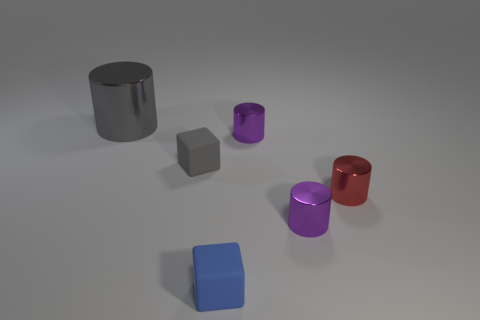There is a gray thing in front of the tiny purple cylinder that is behind the tiny gray matte block; what is its shape?
Ensure brevity in your answer.  Cube. Are there any tiny red cylinders made of the same material as the large cylinder?
Your answer should be compact. Yes. The other small matte object that is the same shape as the blue rubber thing is what color?
Your answer should be very brief. Gray. Is the number of red objects behind the gray matte block less than the number of gray metallic cylinders on the right side of the blue block?
Offer a very short reply. No. What number of other objects are there of the same shape as the tiny red metal object?
Provide a short and direct response. 3. Is the number of blue blocks behind the red object less than the number of small green shiny balls?
Ensure brevity in your answer.  No. There is a small block behind the tiny blue cube; what is its material?
Give a very brief answer. Rubber. What number of other objects are the same size as the gray metallic thing?
Provide a short and direct response. 0. Is the number of small red shiny cylinders less than the number of big purple objects?
Provide a short and direct response. No. There is a large metal object; what shape is it?
Give a very brief answer. Cylinder. 